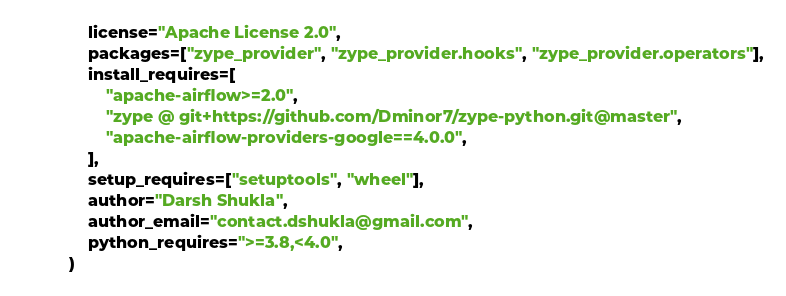<code> <loc_0><loc_0><loc_500><loc_500><_Python_>    license="Apache License 2.0",
    packages=["zype_provider", "zype_provider.hooks", "zype_provider.operators"],
    install_requires=[
        "apache-airflow>=2.0",
        "zype @ git+https://github.com/Dminor7/zype-python.git@master",
        "apache-airflow-providers-google==4.0.0",
    ],
    setup_requires=["setuptools", "wheel"],
    author="Darsh Shukla",
    author_email="contact.dshukla@gmail.com",
    python_requires=">=3.8,<4.0",
)
</code> 